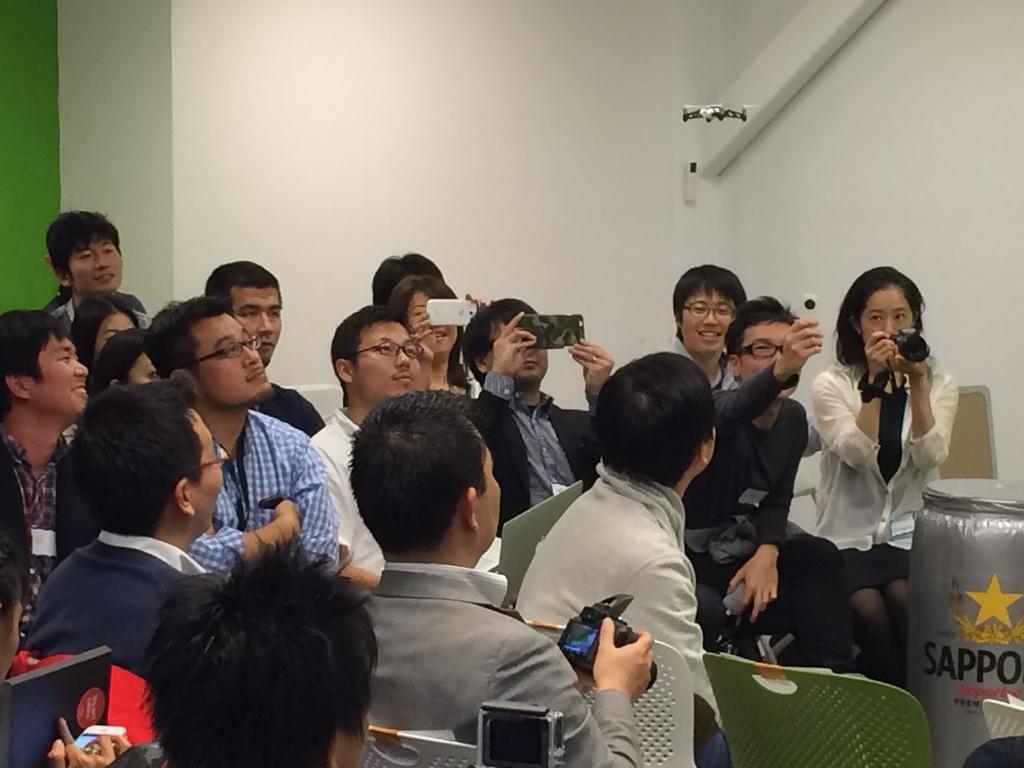How would you summarize this image in a sentence or two? This is an inside view of a room. Here I can see few people looking at the right side. Few people are holding mobiles, cameras in their hands and capturing the pictures. At the bottom there are few chairs. In the background there is a wall. 